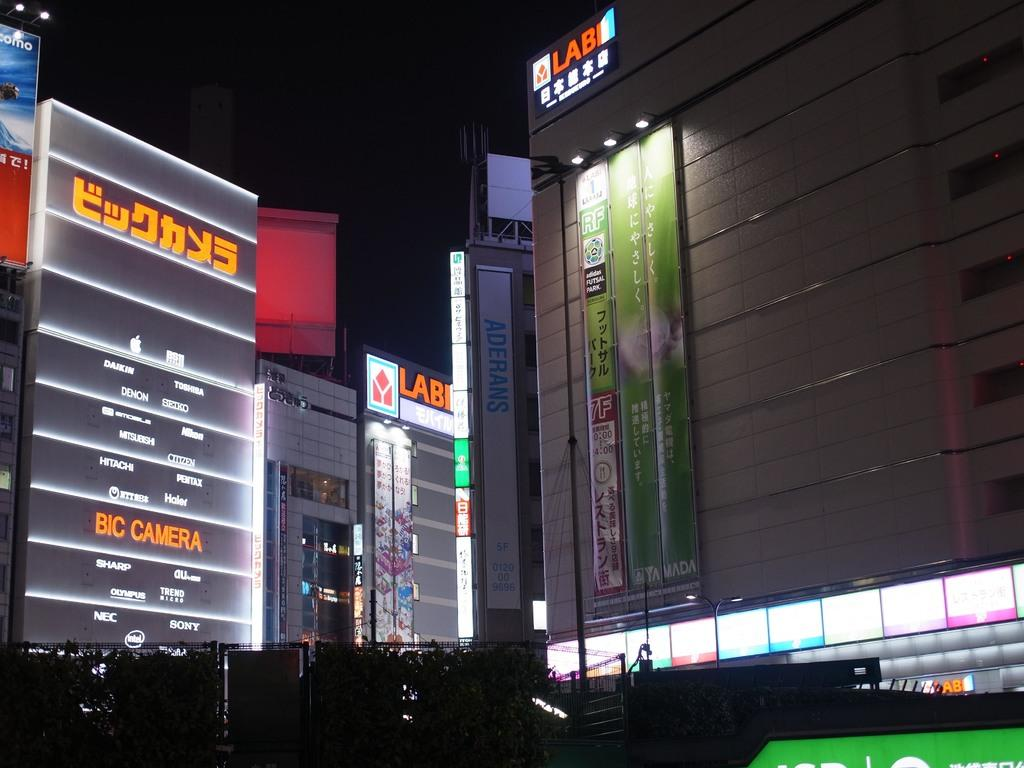<image>
Offer a succinct explanation of the picture presented. A large building with the word LABI in orange at top. 